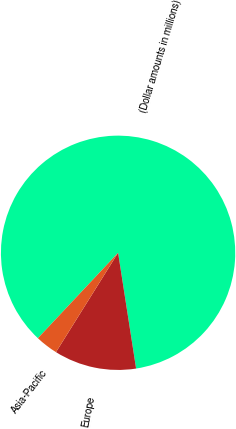Convert chart to OTSL. <chart><loc_0><loc_0><loc_500><loc_500><pie_chart><fcel>(Dollar amounts in millions)<fcel>Europe<fcel>Asia-Pacific<nl><fcel>85.55%<fcel>11.35%<fcel>3.11%<nl></chart> 